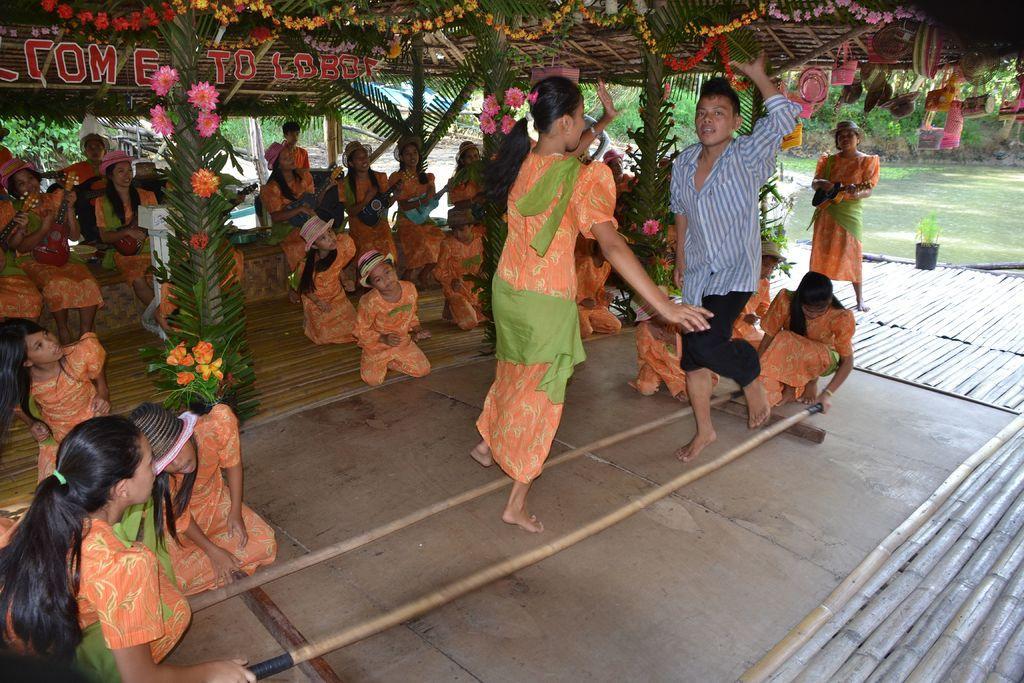In one or two sentences, can you explain what this image depicts? In this picture there is a woman who is wearing orange dress. Beside her there is a boy who is wearing shirt and trouser. Both of them are dancing. Besides them there are two girls who are holding two bamboo sticks. On the left I can see many girls wearing the same dress and they are sitting under the shed. In the background I can see many trees, plants and grass. In the bottom right corner I can see many bamboos. 